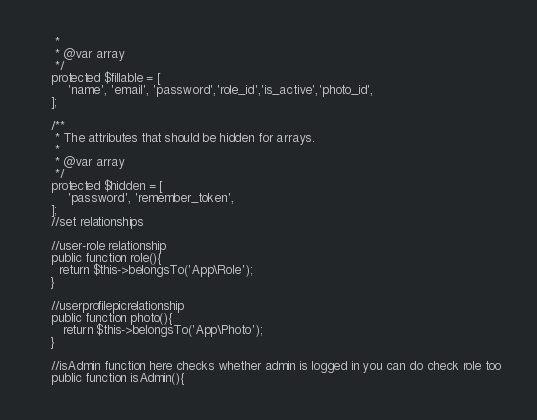Convert code to text. <code><loc_0><loc_0><loc_500><loc_500><_PHP_>     *
     * @var array
     */
    protected $fillable = [
        'name', 'email', 'password','role_id','is_active','photo_id',
    ];

    /**
     * The attributes that should be hidden for arrays.
     *
     * @var array
     */
    protected $hidden = [
        'password', 'remember_token',
    ];
    //set relationships

    //user-role relationship
    public function role(){
      return $this->belongsTo('App\Role');
    }

    //userprofilepicrelationship
    public function photo(){
       return $this->belongsTo('App\Photo');
    }

    //isAdmin function here checks whether admin is logged in you can do check role too
    public function isAdmin(){</code> 